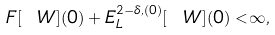<formula> <loc_0><loc_0><loc_500><loc_500>F [ \ W ] ( 0 ) + E ^ { 2 - \delta , ( 0 ) } _ { L } [ \ W ] ( 0 ) < \infty ,</formula> 